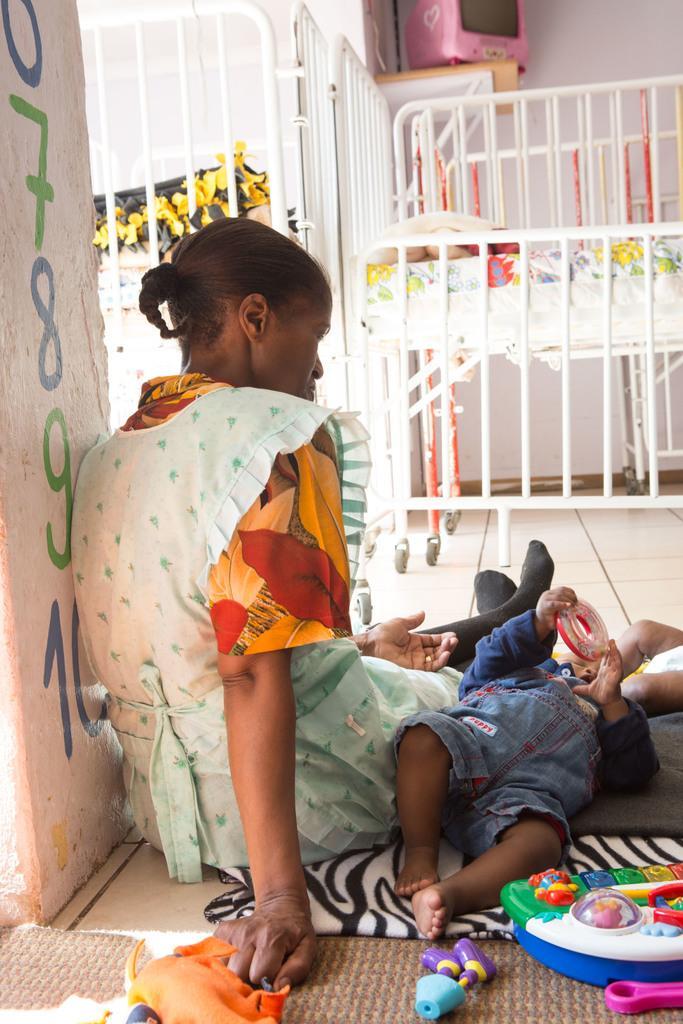Please provide a concise description of this image. In this picture I can see there is a woman sitting and there is an infant next to her, the infant is holding a toy and there are few toys placed on the floor, there is a cradle in the backdrop. There is a pillar at left side and there are few numbers written on it. 